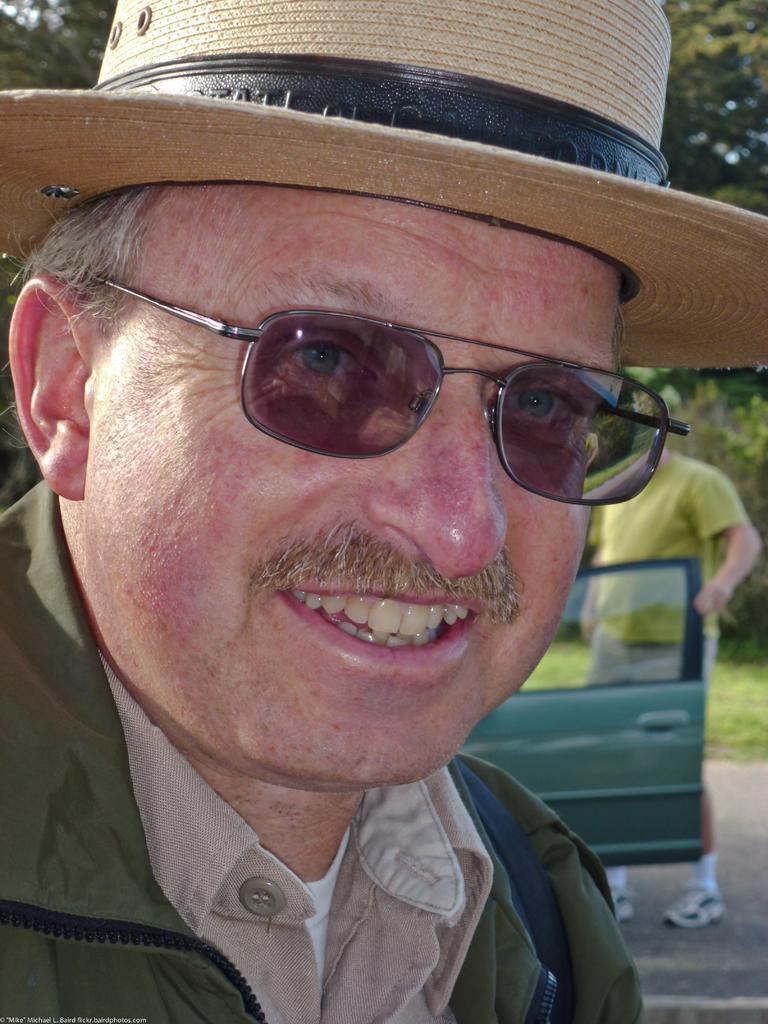Can you describe this image briefly? In the image there is a man, he is laughing and behind him there is another person, he is holding the door of a vehicle. 